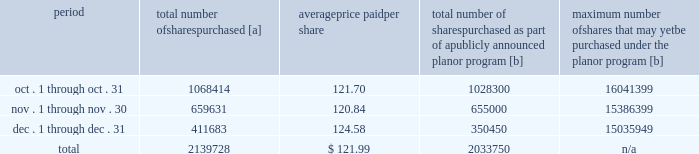Five-year performance comparison 2013 the following graph provides an indicator of cumulative total shareholder returns for the corporation as compared to the peer group index ( described above ) , the dj trans , and the s&p 500 .
The graph assumes that $ 100 was invested in the common stock of union pacific corporation and each index on december 31 , 2007 and that all dividends were reinvested .
Purchases of equity securities 2013 during 2012 , we repurchased 13804709 shares of our common stock at an average price of $ 115.33 .
The table presents common stock repurchases during each month for the fourth quarter of 2012 : period total number of shares purchased [a] average price paid per share total number of shares purchased as part of a publicly announced plan or program [b] maximum number of shares that may yet be purchased under the plan or program [b] .
[a] total number of shares purchased during the quarter includes approximately 105978 shares delivered or attested to upc by employees to pay stock option exercise prices , satisfy excess tax withholding obligations for stock option exercises or vesting of retention units , and pay withholding obligations for vesting of retention shares .
[b] on april 1 , 2011 , our board of directors authorized the repurchase of up to 40 million shares of our common stock by march 31 , 2014 .
These repurchases may be made on the open market or through other transactions .
Our management has sole discretion with respect to determining the timing and amount of these transactions. .
What percentage of the total number of shares purchased were purchased in november? 
Computations: (659631 / 2139728)
Answer: 0.30828. 